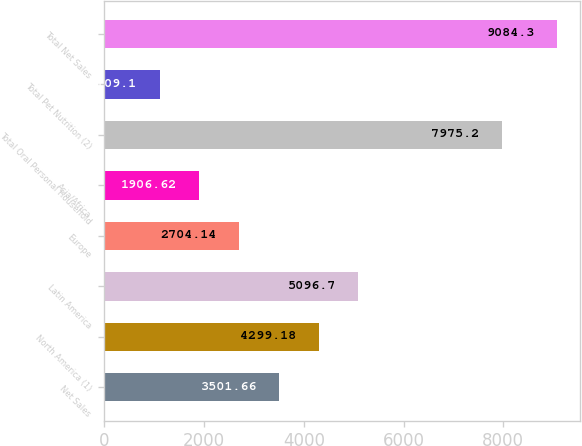<chart> <loc_0><loc_0><loc_500><loc_500><bar_chart><fcel>Net Sales<fcel>North America (1)<fcel>Latin America<fcel>Europe<fcel>Asia/Africa<fcel>Total Oral Personal Household<fcel>Total Pet Nutrition (2)<fcel>Total Net Sales<nl><fcel>3501.66<fcel>4299.18<fcel>5096.7<fcel>2704.14<fcel>1906.62<fcel>7975.2<fcel>1109.1<fcel>9084.3<nl></chart> 